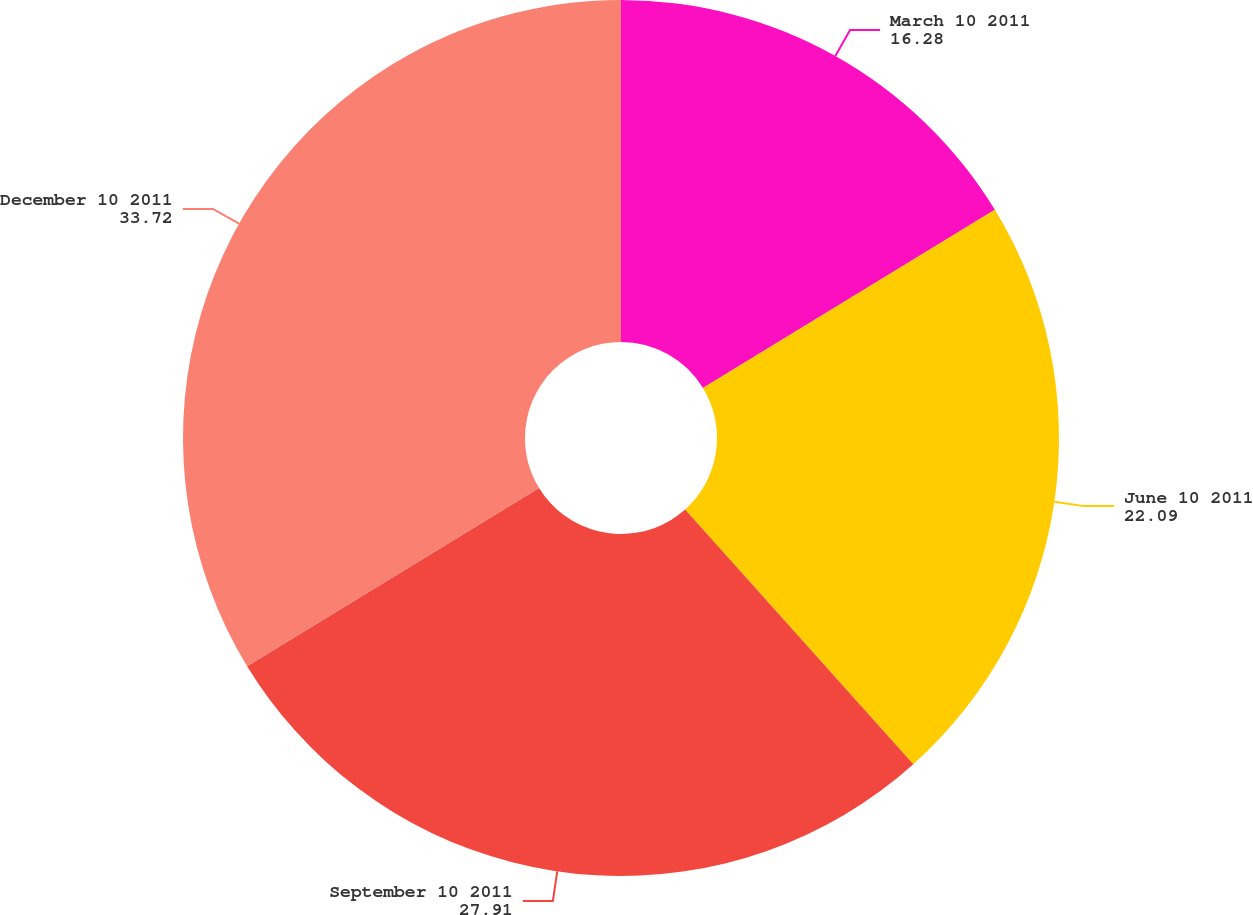Convert chart to OTSL. <chart><loc_0><loc_0><loc_500><loc_500><pie_chart><fcel>March 10 2011<fcel>June 10 2011<fcel>September 10 2011<fcel>December 10 2011<nl><fcel>16.28%<fcel>22.09%<fcel>27.91%<fcel>33.72%<nl></chart> 